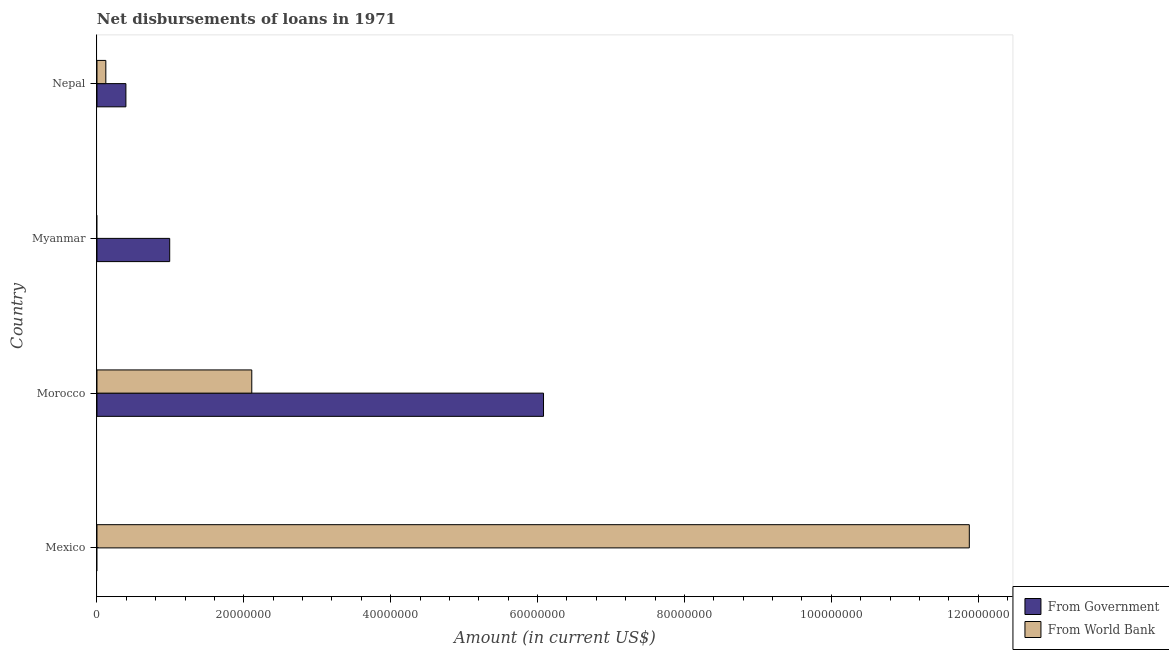How many different coloured bars are there?
Your answer should be very brief. 2. Are the number of bars on each tick of the Y-axis equal?
Ensure brevity in your answer.  No. What is the label of the 3rd group of bars from the top?
Provide a succinct answer. Morocco. What is the net disbursements of loan from government in Morocco?
Keep it short and to the point. 6.08e+07. Across all countries, what is the maximum net disbursements of loan from world bank?
Ensure brevity in your answer.  1.19e+08. Across all countries, what is the minimum net disbursements of loan from world bank?
Your response must be concise. 0. In which country was the net disbursements of loan from world bank maximum?
Provide a short and direct response. Mexico. What is the total net disbursements of loan from government in the graph?
Ensure brevity in your answer.  7.47e+07. What is the difference between the net disbursements of loan from government in Morocco and that in Nepal?
Your answer should be very brief. 5.69e+07. What is the difference between the net disbursements of loan from world bank in Mexico and the net disbursements of loan from government in Myanmar?
Offer a very short reply. 1.09e+08. What is the average net disbursements of loan from world bank per country?
Make the answer very short. 3.53e+07. What is the difference between the net disbursements of loan from world bank and net disbursements of loan from government in Nepal?
Offer a very short reply. -2.73e+06. In how many countries, is the net disbursements of loan from world bank greater than 84000000 US$?
Provide a short and direct response. 1. What is the ratio of the net disbursements of loan from government in Morocco to that in Myanmar?
Offer a terse response. 6.14. Is the net disbursements of loan from world bank in Mexico less than that in Morocco?
Offer a very short reply. No. What is the difference between the highest and the second highest net disbursements of loan from world bank?
Your answer should be very brief. 9.77e+07. What is the difference between the highest and the lowest net disbursements of loan from world bank?
Make the answer very short. 1.19e+08. Are all the bars in the graph horizontal?
Provide a succinct answer. Yes. How many countries are there in the graph?
Provide a short and direct response. 4. What is the difference between two consecutive major ticks on the X-axis?
Offer a terse response. 2.00e+07. Does the graph contain grids?
Offer a very short reply. No. How are the legend labels stacked?
Your answer should be compact. Vertical. What is the title of the graph?
Your response must be concise. Net disbursements of loans in 1971. What is the label or title of the Y-axis?
Keep it short and to the point. Country. What is the Amount (in current US$) in From Government in Mexico?
Your response must be concise. 0. What is the Amount (in current US$) of From World Bank in Mexico?
Ensure brevity in your answer.  1.19e+08. What is the Amount (in current US$) in From Government in Morocco?
Offer a very short reply. 6.08e+07. What is the Amount (in current US$) in From World Bank in Morocco?
Offer a terse response. 2.11e+07. What is the Amount (in current US$) in From Government in Myanmar?
Provide a succinct answer. 9.90e+06. What is the Amount (in current US$) of From World Bank in Myanmar?
Your answer should be compact. 0. What is the Amount (in current US$) in From Government in Nepal?
Give a very brief answer. 3.94e+06. What is the Amount (in current US$) in From World Bank in Nepal?
Keep it short and to the point. 1.21e+06. Across all countries, what is the maximum Amount (in current US$) of From Government?
Provide a succinct answer. 6.08e+07. Across all countries, what is the maximum Amount (in current US$) of From World Bank?
Give a very brief answer. 1.19e+08. Across all countries, what is the minimum Amount (in current US$) in From Government?
Provide a succinct answer. 0. Across all countries, what is the minimum Amount (in current US$) of From World Bank?
Make the answer very short. 0. What is the total Amount (in current US$) in From Government in the graph?
Provide a succinct answer. 7.47e+07. What is the total Amount (in current US$) in From World Bank in the graph?
Your answer should be compact. 1.41e+08. What is the difference between the Amount (in current US$) in From World Bank in Mexico and that in Morocco?
Give a very brief answer. 9.77e+07. What is the difference between the Amount (in current US$) of From World Bank in Mexico and that in Nepal?
Your response must be concise. 1.18e+08. What is the difference between the Amount (in current US$) of From Government in Morocco and that in Myanmar?
Your answer should be compact. 5.09e+07. What is the difference between the Amount (in current US$) of From Government in Morocco and that in Nepal?
Offer a very short reply. 5.69e+07. What is the difference between the Amount (in current US$) of From World Bank in Morocco and that in Nepal?
Offer a very short reply. 1.99e+07. What is the difference between the Amount (in current US$) of From Government in Myanmar and that in Nepal?
Give a very brief answer. 5.96e+06. What is the difference between the Amount (in current US$) of From Government in Morocco and the Amount (in current US$) of From World Bank in Nepal?
Your response must be concise. 5.96e+07. What is the difference between the Amount (in current US$) in From Government in Myanmar and the Amount (in current US$) in From World Bank in Nepal?
Ensure brevity in your answer.  8.70e+06. What is the average Amount (in current US$) of From Government per country?
Your answer should be compact. 1.87e+07. What is the average Amount (in current US$) of From World Bank per country?
Provide a short and direct response. 3.53e+07. What is the difference between the Amount (in current US$) of From Government and Amount (in current US$) of From World Bank in Morocco?
Give a very brief answer. 3.97e+07. What is the difference between the Amount (in current US$) of From Government and Amount (in current US$) of From World Bank in Nepal?
Your answer should be very brief. 2.73e+06. What is the ratio of the Amount (in current US$) in From World Bank in Mexico to that in Morocco?
Provide a succinct answer. 5.63. What is the ratio of the Amount (in current US$) of From World Bank in Mexico to that in Nepal?
Your answer should be very brief. 98.42. What is the ratio of the Amount (in current US$) of From Government in Morocco to that in Myanmar?
Provide a succinct answer. 6.14. What is the ratio of the Amount (in current US$) of From Government in Morocco to that in Nepal?
Give a very brief answer. 15.43. What is the ratio of the Amount (in current US$) of From World Bank in Morocco to that in Nepal?
Give a very brief answer. 17.47. What is the ratio of the Amount (in current US$) of From Government in Myanmar to that in Nepal?
Ensure brevity in your answer.  2.51. What is the difference between the highest and the second highest Amount (in current US$) of From Government?
Offer a very short reply. 5.09e+07. What is the difference between the highest and the second highest Amount (in current US$) in From World Bank?
Keep it short and to the point. 9.77e+07. What is the difference between the highest and the lowest Amount (in current US$) in From Government?
Make the answer very short. 6.08e+07. What is the difference between the highest and the lowest Amount (in current US$) of From World Bank?
Your response must be concise. 1.19e+08. 